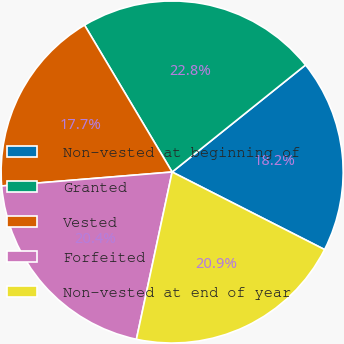Convert chart. <chart><loc_0><loc_0><loc_500><loc_500><pie_chart><fcel>Non-vested at beginning of<fcel>Granted<fcel>Vested<fcel>Forfeited<fcel>Non-vested at end of year<nl><fcel>18.25%<fcel>22.8%<fcel>17.74%<fcel>20.35%<fcel>20.86%<nl></chart> 